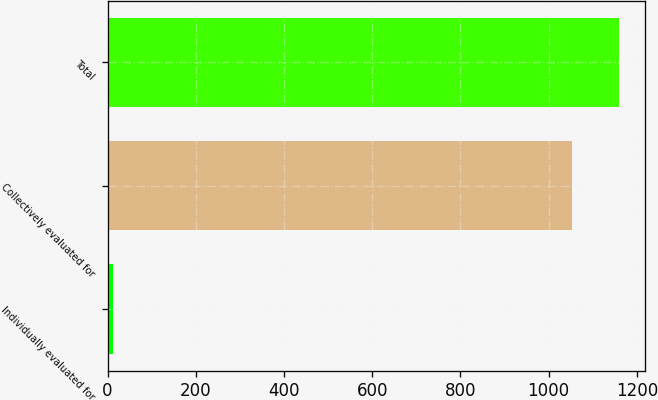Convert chart to OTSL. <chart><loc_0><loc_0><loc_500><loc_500><bar_chart><fcel>Individually evaluated for<fcel>Collectively evaluated for<fcel>Total<nl><fcel>12<fcel>1054<fcel>1159.4<nl></chart> 